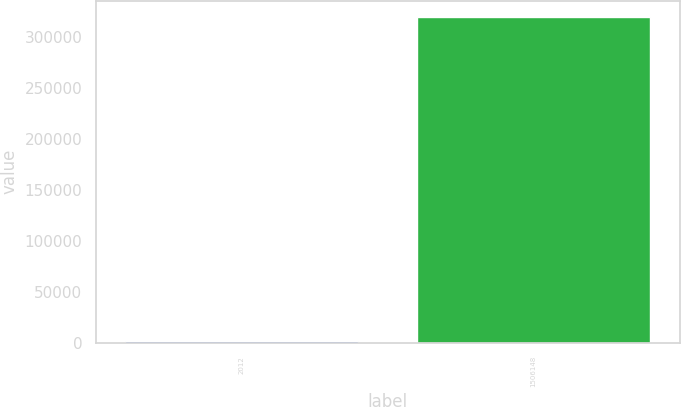<chart> <loc_0><loc_0><loc_500><loc_500><bar_chart><fcel>2012<fcel>1506148<nl><fcel>2011<fcel>320143<nl></chart> 